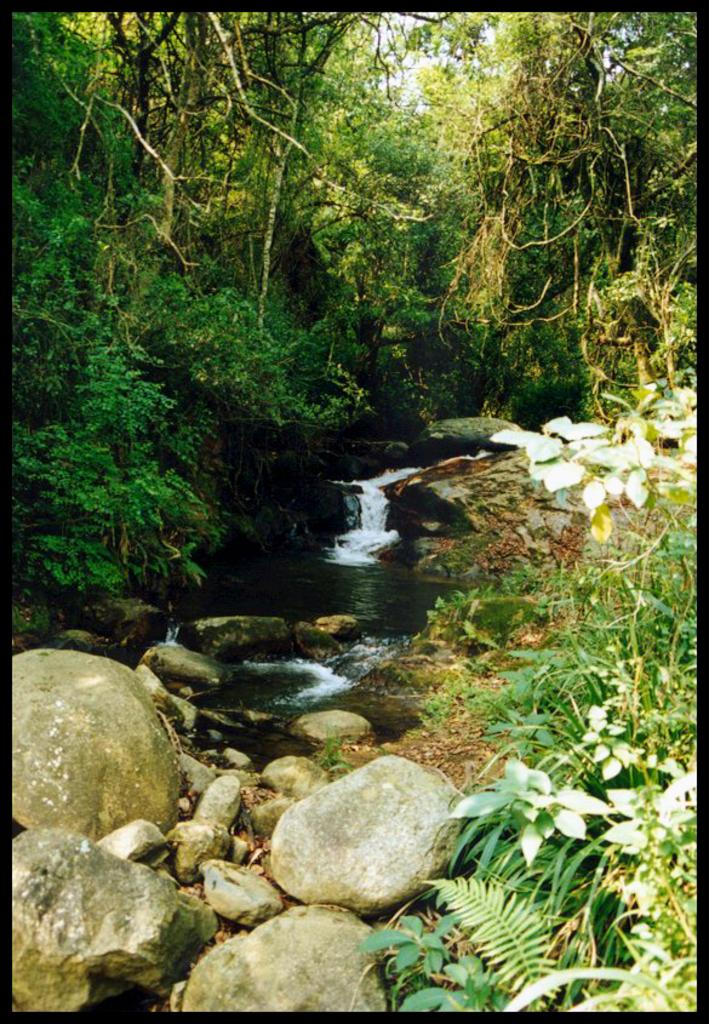What is the main feature in the image? There is a waterfall in the image. What can be seen around the waterfall? There are stones and trees around the waterfall. What type of frame is around the waterfall in the image? There is no frame around the waterfall in the image. 